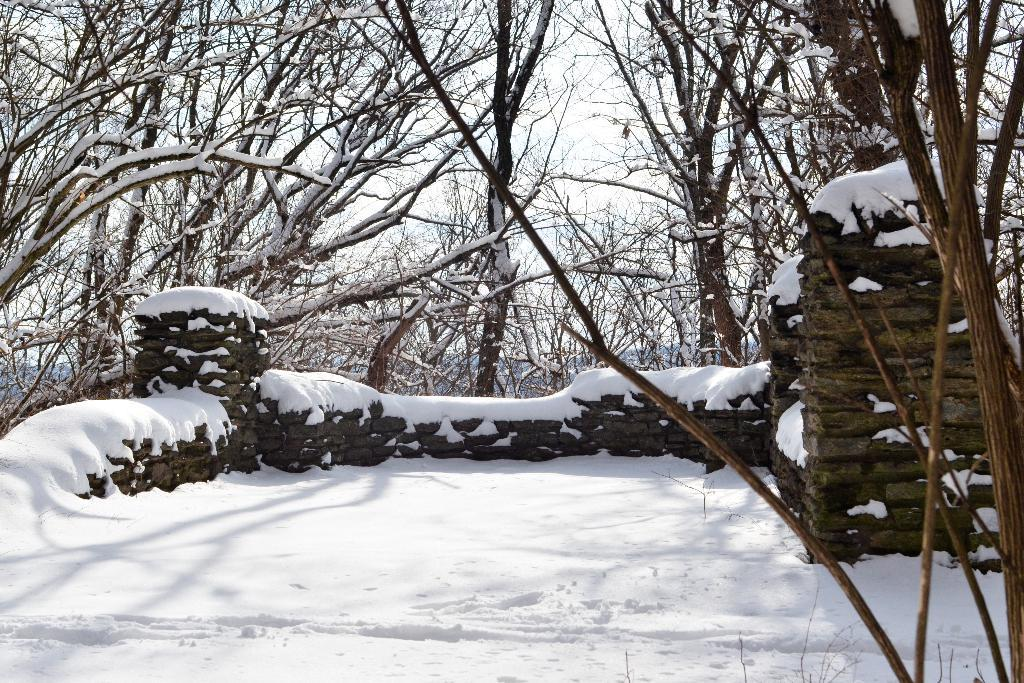What type of weather condition is depicted in the image? There is snow in the image, indicating a cold or wintry weather condition. What structure can be seen in the image? There is a wall in the image. What type of vegetation is present in the image? There are trees in the image. What is visible in the background of the image? The sky is visible in the image. Can you see a frog hopping on the wall in the image? There is no frog present in the image, and therefore no such activity can be observed. 